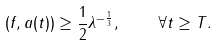<formula> <loc_0><loc_0><loc_500><loc_500>( f , a ( t ) ) \geq \frac { 1 } { 2 } \lambda ^ { - \frac { 1 } { 3 } } , \quad \forall t \geq T .</formula> 